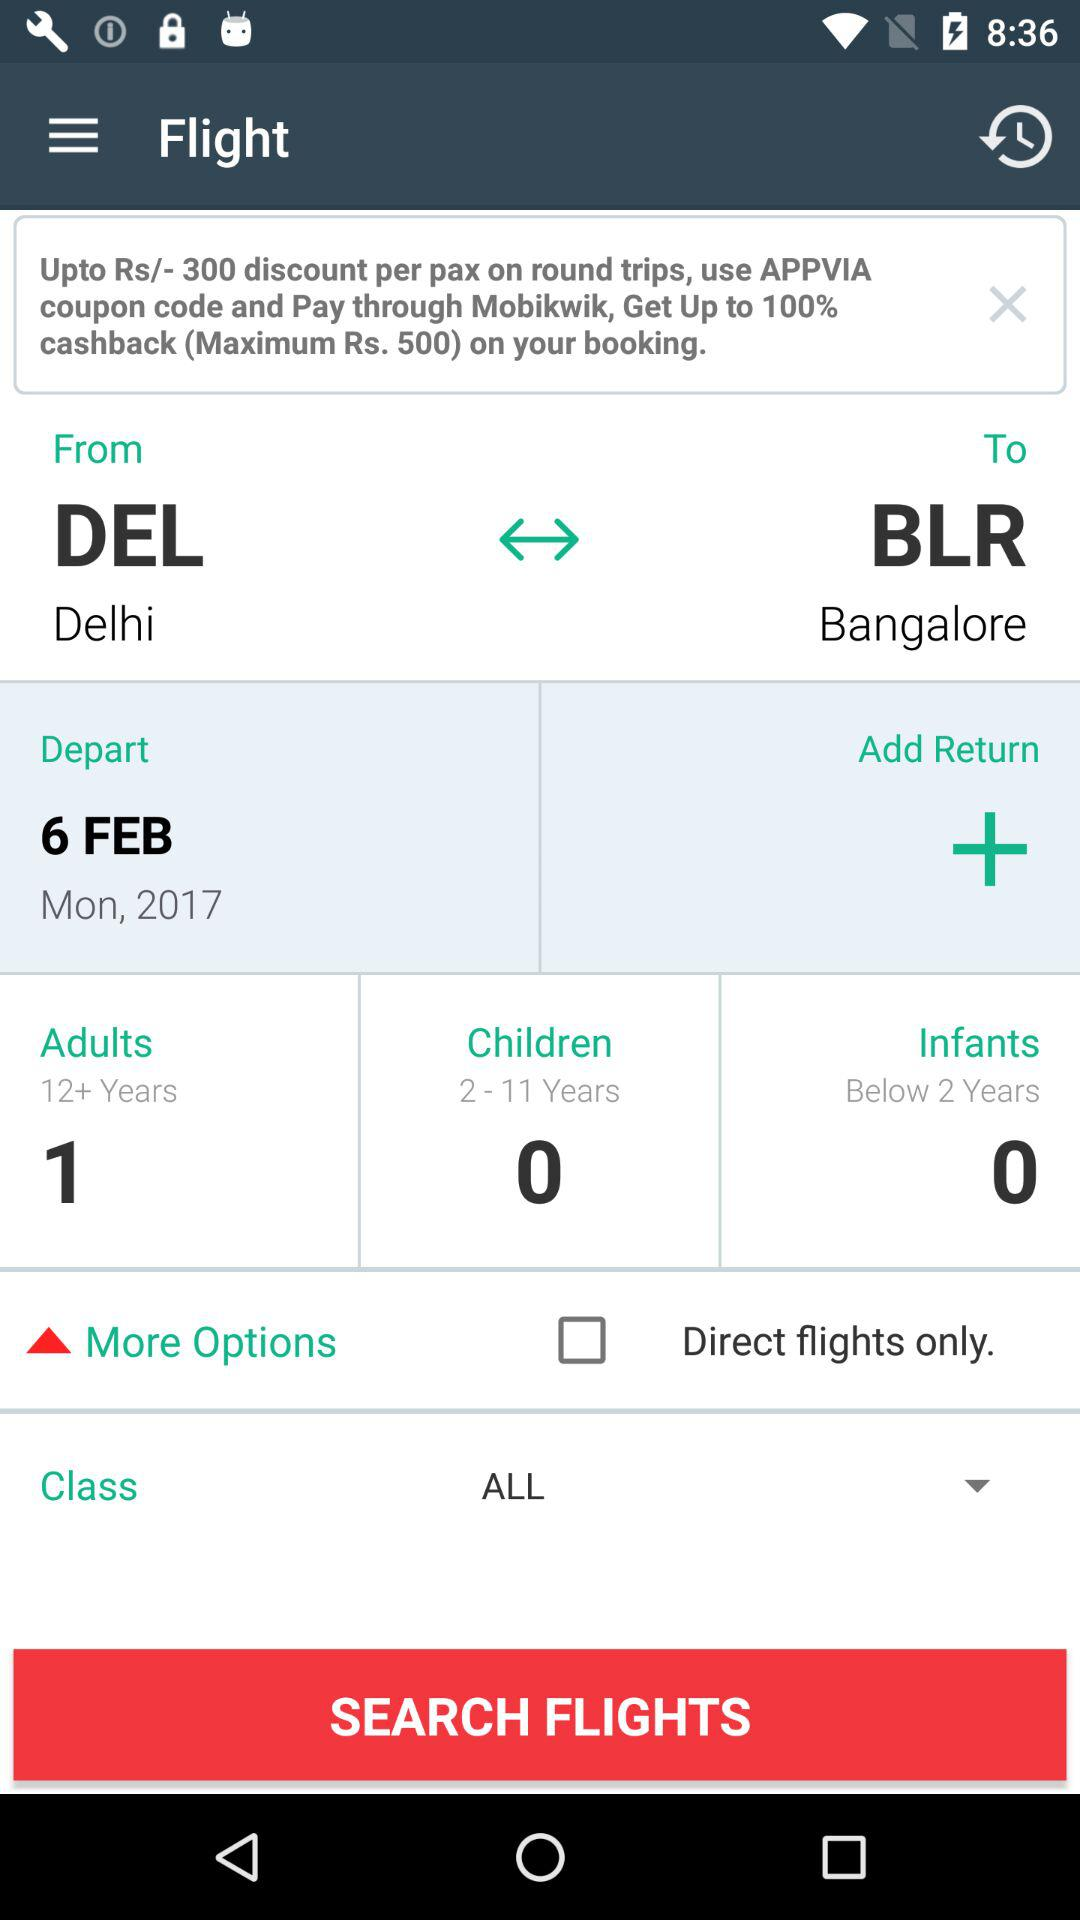What is the date? The date is Monday, February 6, 2017. 